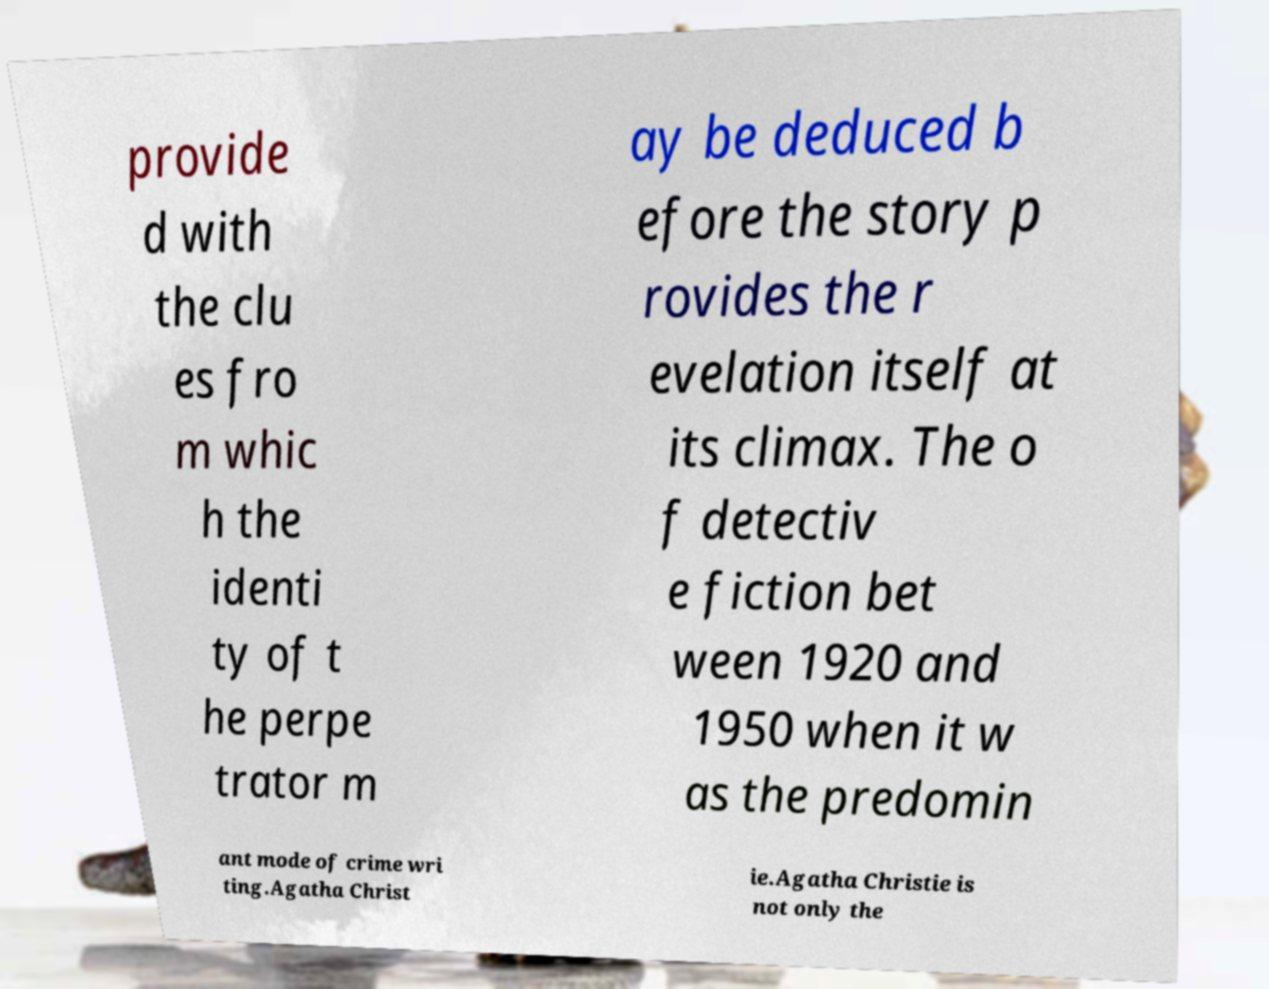Could you assist in decoding the text presented in this image and type it out clearly? provide d with the clu es fro m whic h the identi ty of t he perpe trator m ay be deduced b efore the story p rovides the r evelation itself at its climax. The o f detectiv e fiction bet ween 1920 and 1950 when it w as the predomin ant mode of crime wri ting.Agatha Christ ie.Agatha Christie is not only the 